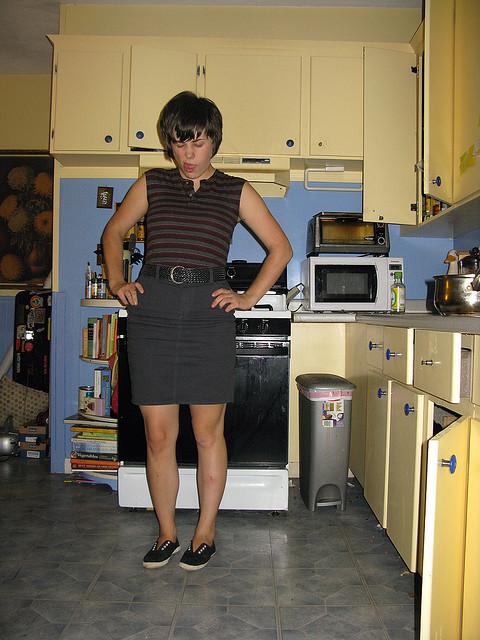Is the microwave door open?
Short answer required. No. How many cabinet doors are open?
Give a very brief answer. 1. Is a male or female pictured?
Give a very brief answer. Female. 